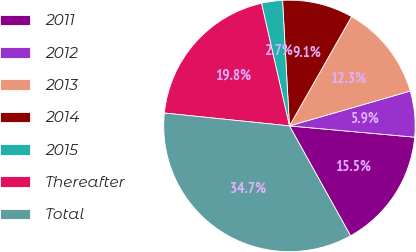Convert chart to OTSL. <chart><loc_0><loc_0><loc_500><loc_500><pie_chart><fcel>2011<fcel>2012<fcel>2013<fcel>2014<fcel>2015<fcel>Thereafter<fcel>Total<nl><fcel>15.5%<fcel>5.9%<fcel>12.3%<fcel>9.1%<fcel>2.7%<fcel>19.8%<fcel>34.71%<nl></chart> 